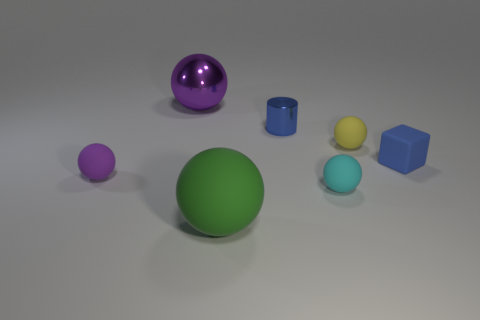There is a big thing that is in front of the tiny blue cube; what is its color?
Offer a terse response. Green. How many other things are there of the same color as the big metal sphere?
Keep it short and to the point. 1. Is the size of the matte sphere that is to the left of the green ball the same as the yellow rubber ball?
Offer a very short reply. Yes. What material is the ball behind the tiny metal cylinder?
Give a very brief answer. Metal. Are there any other things that are the same shape as the small blue rubber thing?
Offer a very short reply. No. What number of metal things are big brown things or tiny yellow spheres?
Your response must be concise. 0. Is the number of large purple things that are on the right side of the tiny blue matte object less than the number of large brown things?
Your answer should be very brief. No. What is the shape of the object to the left of the large purple thing to the right of the matte ball to the left of the big purple metal ball?
Your response must be concise. Sphere. Do the tiny matte cube and the metallic cylinder have the same color?
Give a very brief answer. Yes. Is the number of tiny yellow objects greater than the number of objects?
Provide a succinct answer. No. 